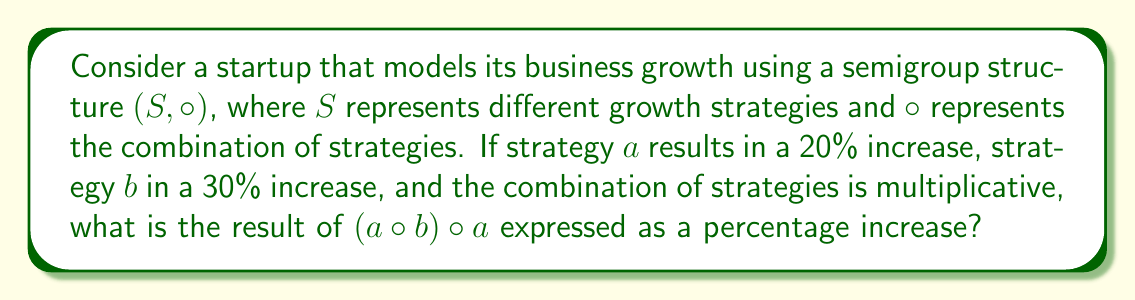What is the answer to this math problem? Let's approach this step-by-step:

1) First, we need to understand what the semigroup structure represents in this context:
   - The set $S$ contains growth strategies
   - The operation $\circ$ represents combining strategies multiplicatively

2) We're given that:
   - Strategy $a$ results in a 20% increase, so we can represent it as 1.20
   - Strategy $b$ results in a 30% increase, so we can represent it as 1.30

3) Now, let's calculate $(a \circ b) \circ a$:

   Step 1: Calculate $a \circ b$
   $a \circ b = 1.20 \times 1.30 = 1.56$
   This represents a 56% increase.

   Step 2: Calculate $(a \circ b) \circ a$
   $(a \circ b) \circ a = 1.56 \times 1.20 = 1.872$

4) To express this as a percentage increase, we subtract 1 and multiply by 100:
   $(1.872 - 1) \times 100 = 0.872 \times 100 = 87.2\%$

This algebraic structure allows us to model complex combinations of growth strategies in a scalable way, which is crucial for startups looking to optimize their business models.
Answer: The result of $(a \circ b) \circ a$ is an 87.2% increase. 